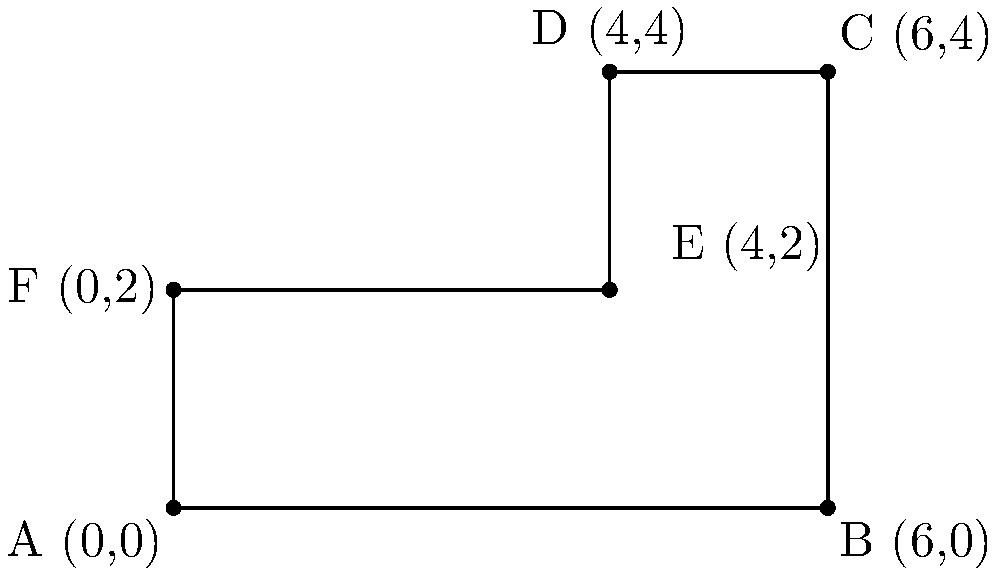As a wrestling promoter, you're tasked with determining the area of an irregularly shaped wrestling mat for an upcoming event. The mat's shape is represented by the coordinates A(0,0), B(6,0), C(6,4), D(4,4), E(4,2), and F(0,2) on a coordinate plane. Calculate the total area of this wrestling mat in square units. To find the area of this irregular shape, we can divide it into two rectangles:

1. Rectangle ABCF:
   Width = 6 - 0 = 6 units
   Height = 2 - 0 = 2 units
   Area of ABCF = $6 \times 2 = 12$ square units

2. Rectangle DEFC:
   Width = 4 - 0 = 4 units
   Height = 4 - 2 = 2 units
   Area of DEFC = $4 \times 2 = 8$ square units

3. Total area:
   Total Area = Area of ABCF + Area of DEFC
               = $12 + 8 = 20$ square units

Therefore, the total area of the irregularly shaped wrestling mat is 20 square units.
Answer: 20 square units 